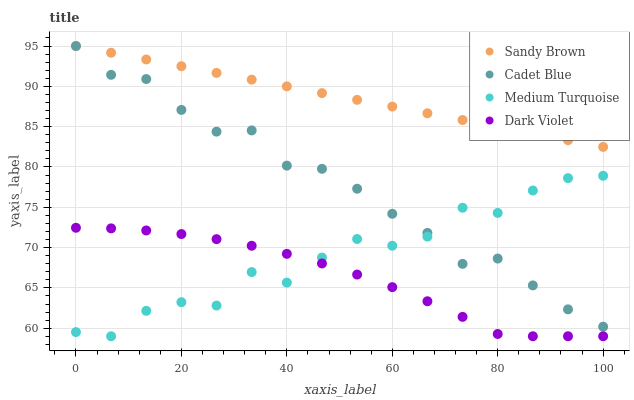Does Dark Violet have the minimum area under the curve?
Answer yes or no. Yes. Does Sandy Brown have the maximum area under the curve?
Answer yes or no. Yes. Does Sandy Brown have the minimum area under the curve?
Answer yes or no. No. Does Dark Violet have the maximum area under the curve?
Answer yes or no. No. Is Sandy Brown the smoothest?
Answer yes or no. Yes. Is Medium Turquoise the roughest?
Answer yes or no. Yes. Is Dark Violet the smoothest?
Answer yes or no. No. Is Dark Violet the roughest?
Answer yes or no. No. Does Dark Violet have the lowest value?
Answer yes or no. Yes. Does Sandy Brown have the lowest value?
Answer yes or no. No. Does Sandy Brown have the highest value?
Answer yes or no. Yes. Does Dark Violet have the highest value?
Answer yes or no. No. Is Dark Violet less than Sandy Brown?
Answer yes or no. Yes. Is Sandy Brown greater than Medium Turquoise?
Answer yes or no. Yes. Does Medium Turquoise intersect Cadet Blue?
Answer yes or no. Yes. Is Medium Turquoise less than Cadet Blue?
Answer yes or no. No. Is Medium Turquoise greater than Cadet Blue?
Answer yes or no. No. Does Dark Violet intersect Sandy Brown?
Answer yes or no. No. 